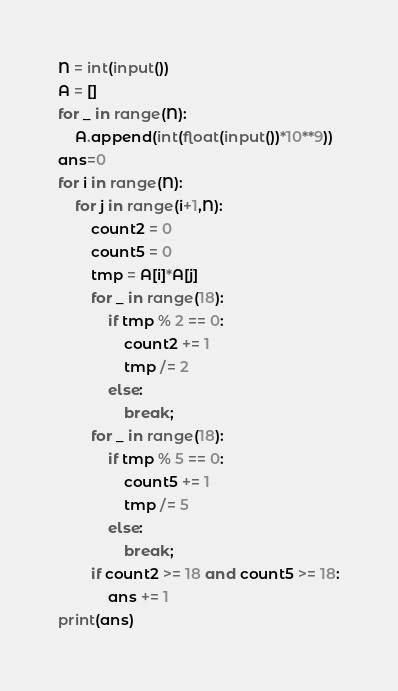<code> <loc_0><loc_0><loc_500><loc_500><_Python_>N = int(input())
A = []
for _ in range(N):
    A.append(int(float(input())*10**9))
ans=0
for i in range(N):
    for j in range(i+1,N):
        count2 = 0
        count5 = 0
        tmp = A[i]*A[j]
        for _ in range(18):
            if tmp % 2 == 0:
                count2 += 1
                tmp /= 2
            else:
                break;
        for _ in range(18):
            if tmp % 5 == 0:
                count5 += 1
                tmp /= 5
            else:
                break;
        if count2 >= 18 and count5 >= 18:
            ans += 1
print(ans)
</code> 